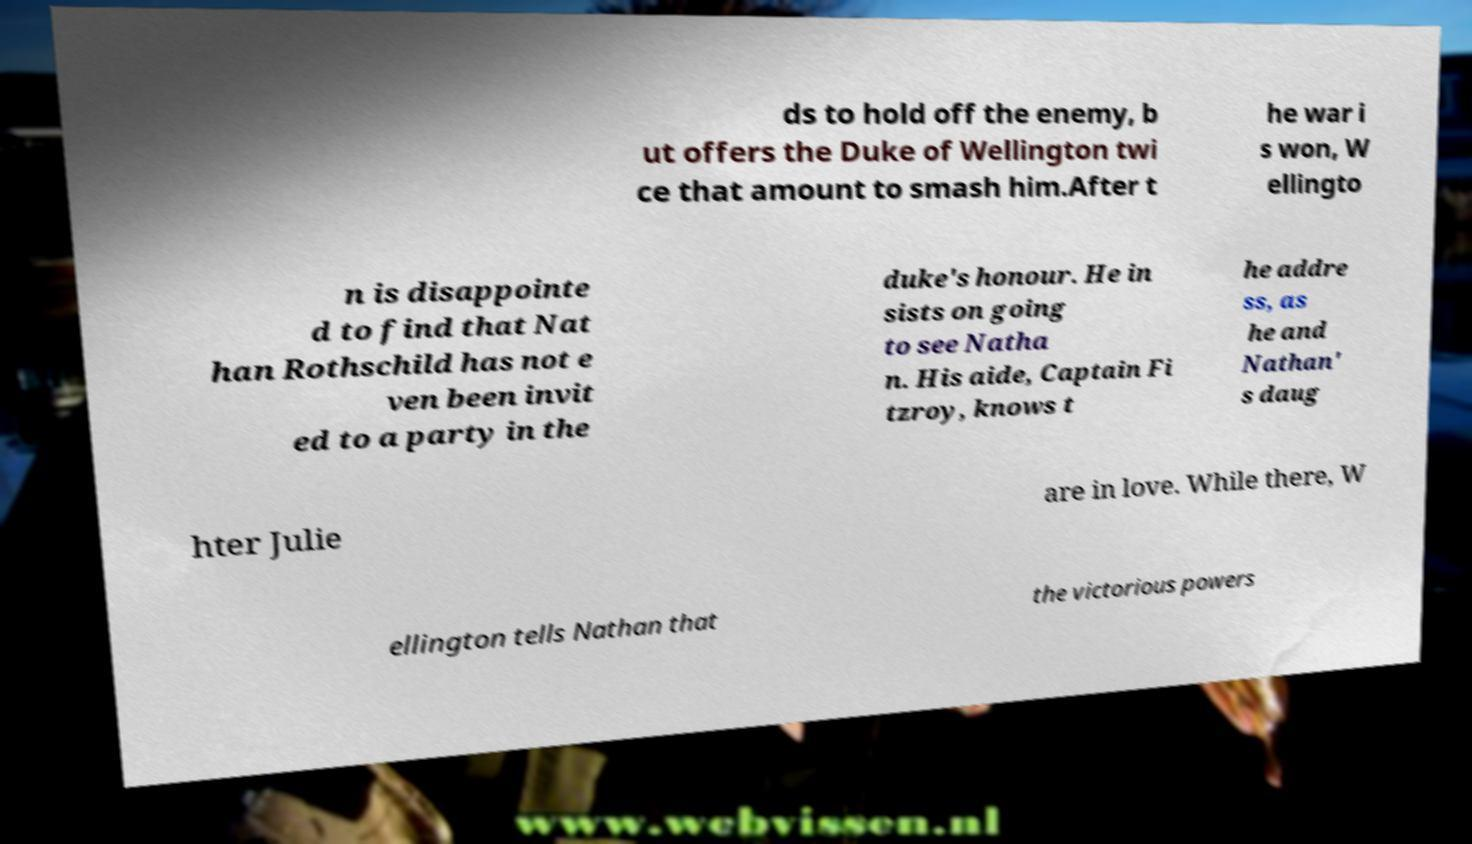I need the written content from this picture converted into text. Can you do that? ds to hold off the enemy, b ut offers the Duke of Wellington twi ce that amount to smash him.After t he war i s won, W ellingto n is disappointe d to find that Nat han Rothschild has not e ven been invit ed to a party in the duke's honour. He in sists on going to see Natha n. His aide, Captain Fi tzroy, knows t he addre ss, as he and Nathan' s daug hter Julie are in love. While there, W ellington tells Nathan that the victorious powers 